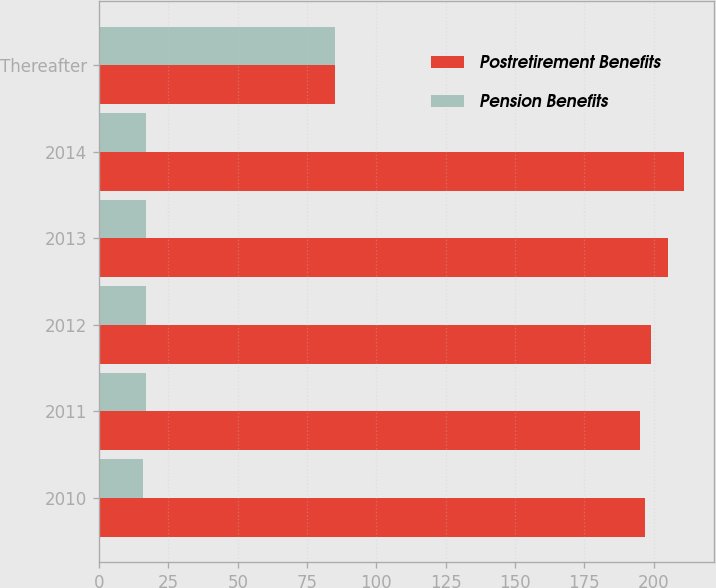<chart> <loc_0><loc_0><loc_500><loc_500><stacked_bar_chart><ecel><fcel>2010<fcel>2011<fcel>2012<fcel>2013<fcel>2014<fcel>Thereafter<nl><fcel>Postretirement Benefits<fcel>197<fcel>195<fcel>199<fcel>205<fcel>211<fcel>85<nl><fcel>Pension Benefits<fcel>16<fcel>17<fcel>17<fcel>17<fcel>17<fcel>85<nl></chart> 